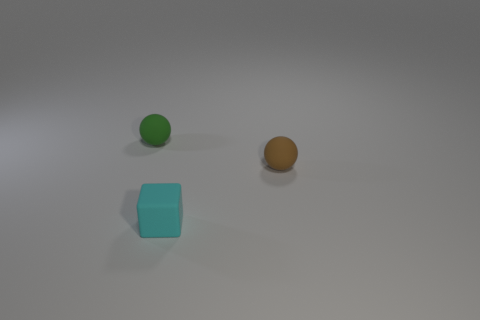Add 1 small cubes. How many objects exist? 4 Subtract all cubes. How many objects are left? 2 Subtract 0 blue cylinders. How many objects are left? 3 Subtract all tiny cyan matte things. Subtract all tiny gray cylinders. How many objects are left? 2 Add 2 tiny brown rubber balls. How many tiny brown rubber balls are left? 3 Add 3 big yellow metallic balls. How many big yellow metallic balls exist? 3 